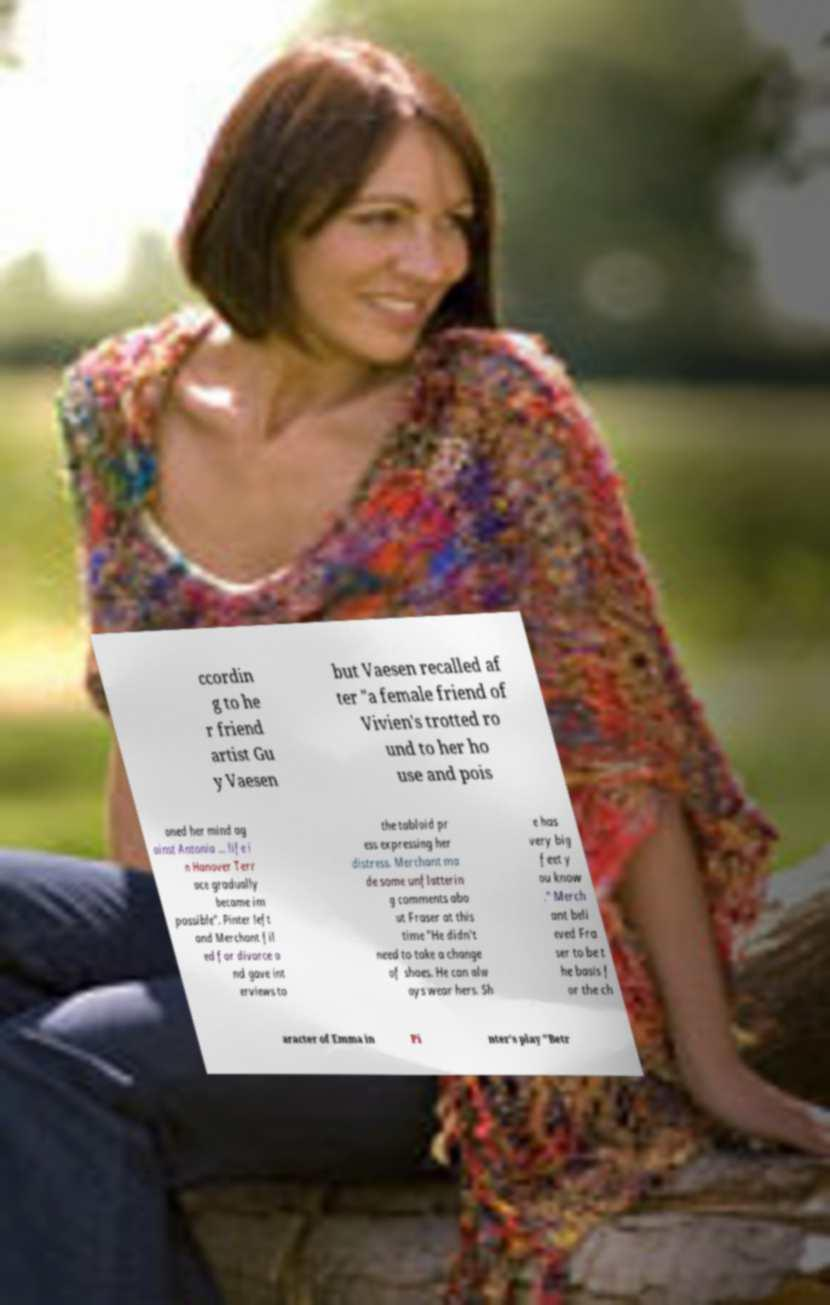Can you read and provide the text displayed in the image?This photo seems to have some interesting text. Can you extract and type it out for me? ccordin g to he r friend artist Gu y Vaesen but Vaesen recalled af ter "a female friend of Vivien's trotted ro und to her ho use and pois oned her mind ag ainst Antonia ... life i n Hanover Terr ace gradually became im possible". Pinter left and Merchant fil ed for divorce a nd gave int erviews to the tabloid pr ess expressing her distress. Merchant ma de some unflatterin g comments abo ut Fraser at this time "He didn't need to take a change of shoes. He can alw ays wear hers. Sh e has very big feet y ou know ." Merch ant beli eved Fra ser to be t he basis f or the ch aracter of Emma in Pi nter's play "Betr 